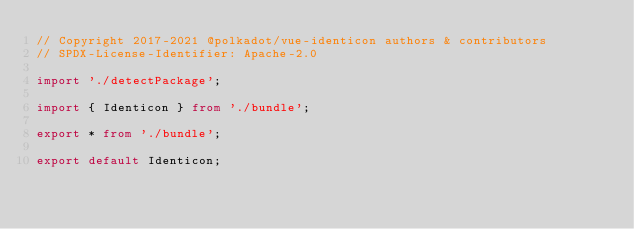<code> <loc_0><loc_0><loc_500><loc_500><_TypeScript_>// Copyright 2017-2021 @polkadot/vue-identicon authors & contributors
// SPDX-License-Identifier: Apache-2.0

import './detectPackage';

import { Identicon } from './bundle';

export * from './bundle';

export default Identicon;
</code> 